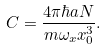<formula> <loc_0><loc_0><loc_500><loc_500>C = \frac { 4 \pi \hbar { a } N } { m \omega _ { x } x _ { 0 } ^ { 3 } } .</formula> 